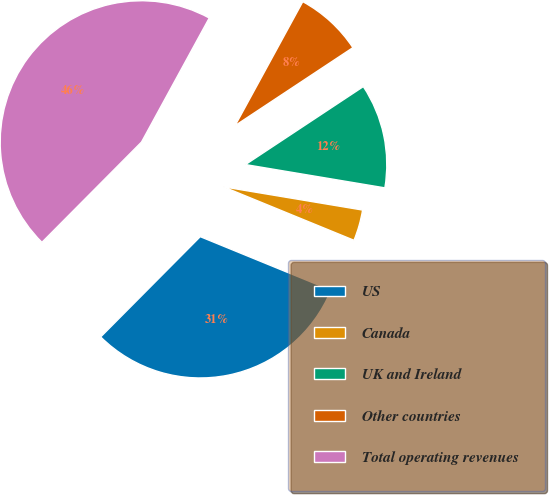Convert chart. <chart><loc_0><loc_0><loc_500><loc_500><pie_chart><fcel>US<fcel>Canada<fcel>UK and Ireland<fcel>Other countries<fcel>Total operating revenues<nl><fcel>31.26%<fcel>3.55%<fcel>11.94%<fcel>7.74%<fcel>45.51%<nl></chart> 